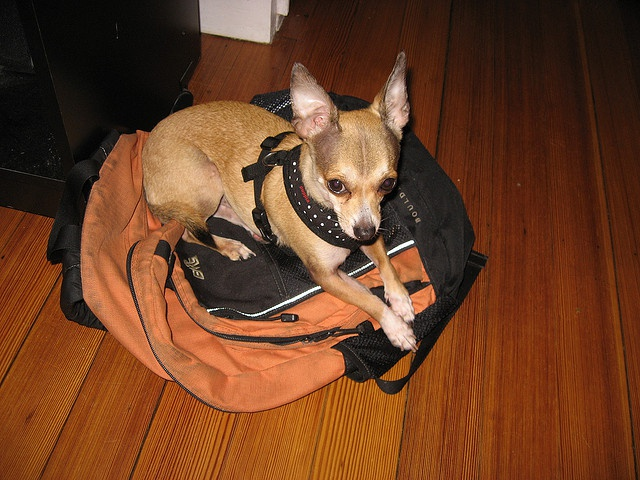Describe the objects in this image and their specific colors. I can see backpack in black, brown, and salmon tones and dog in black and tan tones in this image. 